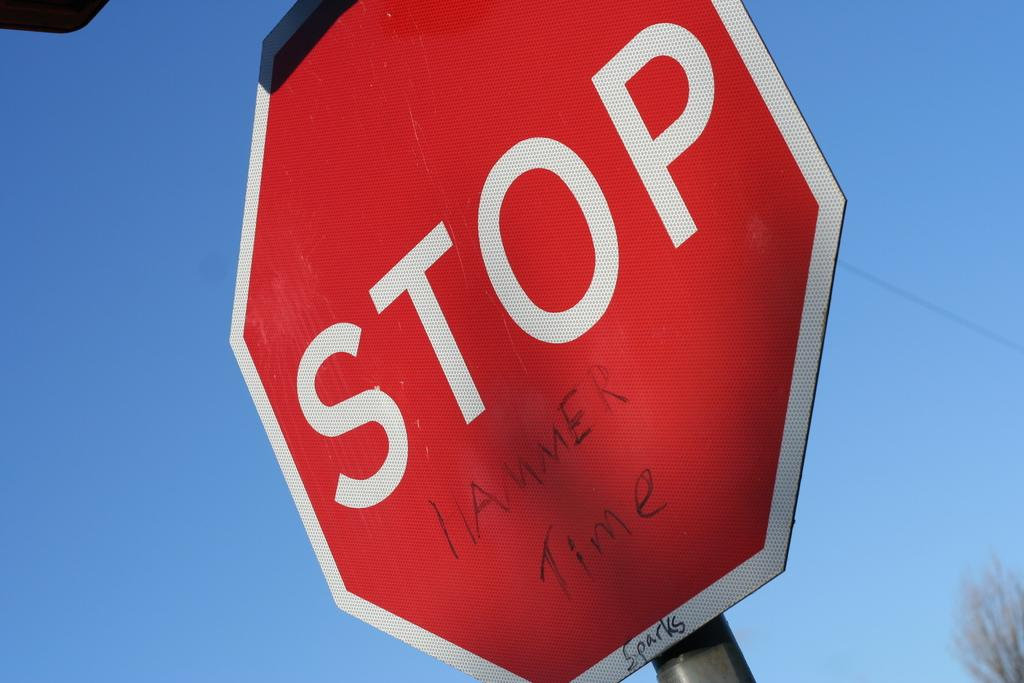<image>
Give a short and clear explanation of the subsequent image. Underneath the word stop, on a stop sign, it says hammer time. 